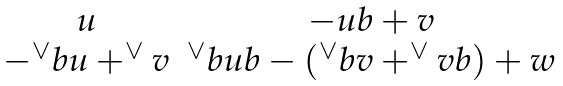<formula> <loc_0><loc_0><loc_500><loc_500>\begin{matrix} u & - u b + v \\ - ^ { \vee } b u + ^ { \vee } v & ^ { \vee } b u b - ( ^ { \vee } b v + ^ { \vee } v b ) + w \\ \end{matrix}</formula> 